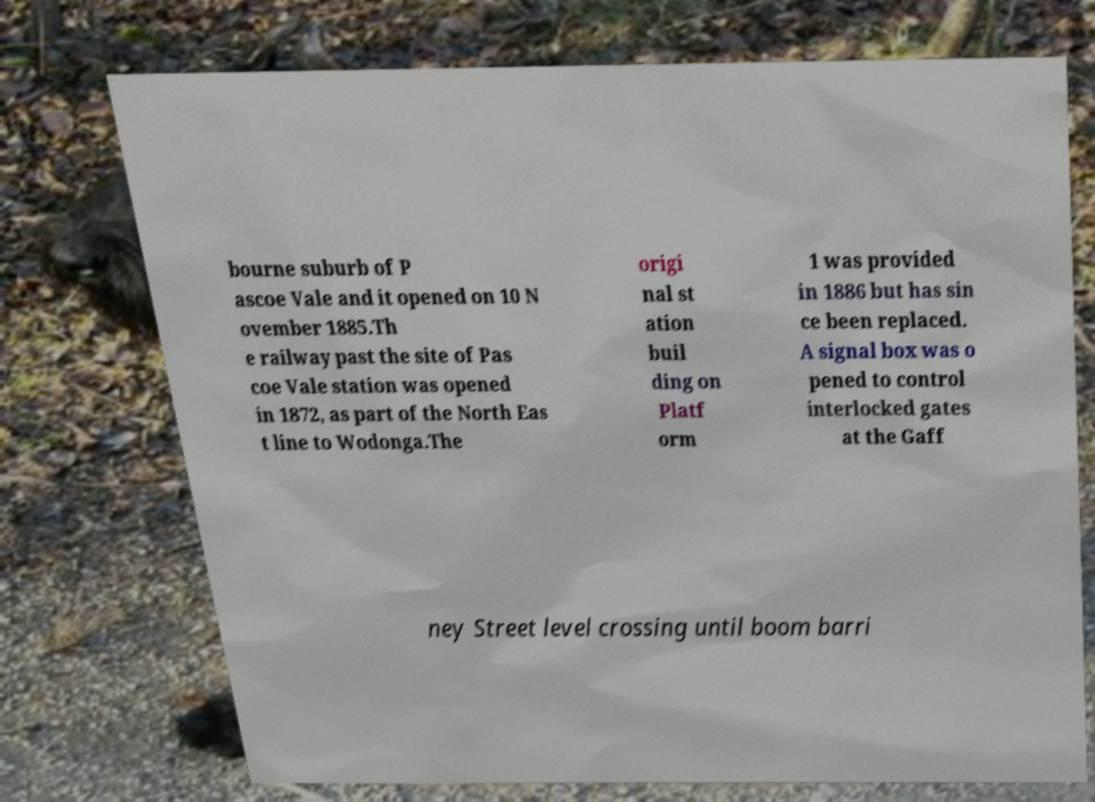Can you read and provide the text displayed in the image?This photo seems to have some interesting text. Can you extract and type it out for me? bourne suburb of P ascoe Vale and it opened on 10 N ovember 1885.Th e railway past the site of Pas coe Vale station was opened in 1872, as part of the North Eas t line to Wodonga.The origi nal st ation buil ding on Platf orm 1 was provided in 1886 but has sin ce been replaced. A signal box was o pened to control interlocked gates at the Gaff ney Street level crossing until boom barri 